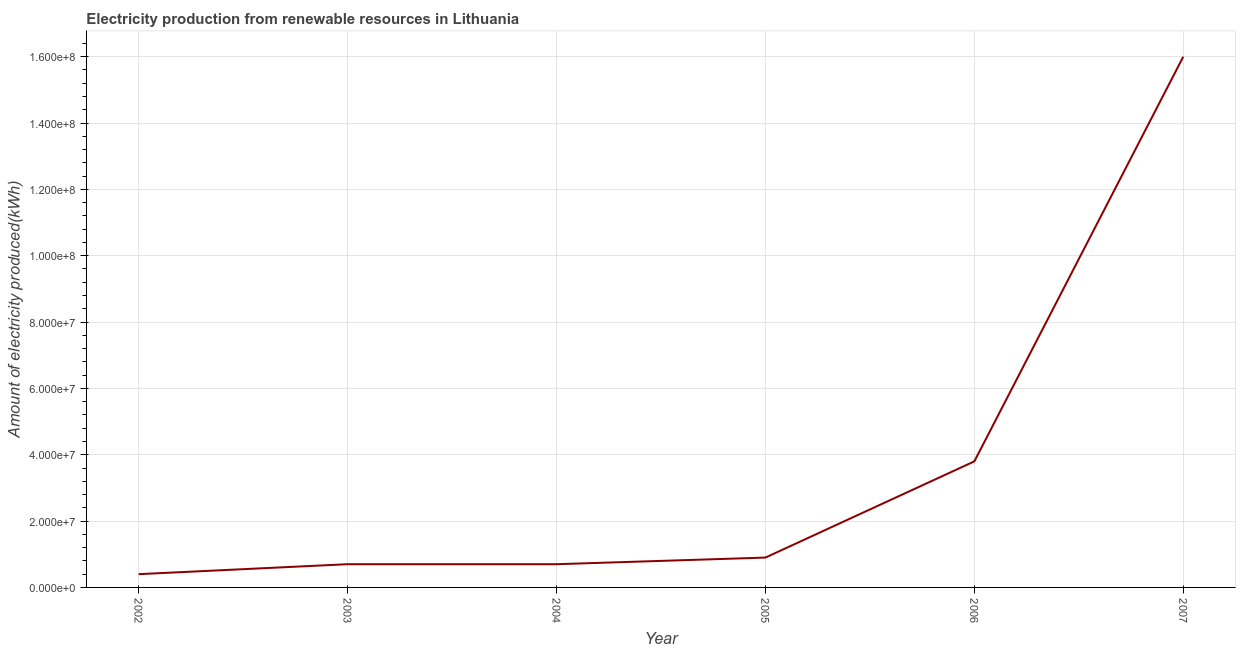What is the amount of electricity produced in 2007?
Your answer should be compact. 1.60e+08. Across all years, what is the maximum amount of electricity produced?
Your answer should be compact. 1.60e+08. Across all years, what is the minimum amount of electricity produced?
Offer a terse response. 4.00e+06. In which year was the amount of electricity produced maximum?
Keep it short and to the point. 2007. In which year was the amount of electricity produced minimum?
Ensure brevity in your answer.  2002. What is the sum of the amount of electricity produced?
Make the answer very short. 2.25e+08. What is the difference between the amount of electricity produced in 2006 and 2007?
Your answer should be compact. -1.22e+08. What is the average amount of electricity produced per year?
Provide a succinct answer. 3.75e+07. In how many years, is the amount of electricity produced greater than 160000000 kWh?
Provide a succinct answer. 0. Do a majority of the years between 2005 and 2007 (inclusive) have amount of electricity produced greater than 76000000 kWh?
Give a very brief answer. No. What is the ratio of the amount of electricity produced in 2005 to that in 2006?
Provide a short and direct response. 0.24. What is the difference between the highest and the second highest amount of electricity produced?
Offer a very short reply. 1.22e+08. Is the sum of the amount of electricity produced in 2004 and 2005 greater than the maximum amount of electricity produced across all years?
Keep it short and to the point. No. What is the difference between the highest and the lowest amount of electricity produced?
Give a very brief answer. 1.56e+08. Does the amount of electricity produced monotonically increase over the years?
Ensure brevity in your answer.  No. How many years are there in the graph?
Provide a short and direct response. 6. What is the difference between two consecutive major ticks on the Y-axis?
Provide a short and direct response. 2.00e+07. What is the title of the graph?
Give a very brief answer. Electricity production from renewable resources in Lithuania. What is the label or title of the X-axis?
Provide a succinct answer. Year. What is the label or title of the Y-axis?
Give a very brief answer. Amount of electricity produced(kWh). What is the Amount of electricity produced(kWh) of 2003?
Give a very brief answer. 7.00e+06. What is the Amount of electricity produced(kWh) in 2004?
Provide a succinct answer. 7.00e+06. What is the Amount of electricity produced(kWh) of 2005?
Ensure brevity in your answer.  9.00e+06. What is the Amount of electricity produced(kWh) in 2006?
Provide a short and direct response. 3.80e+07. What is the Amount of electricity produced(kWh) of 2007?
Ensure brevity in your answer.  1.60e+08. What is the difference between the Amount of electricity produced(kWh) in 2002 and 2003?
Keep it short and to the point. -3.00e+06. What is the difference between the Amount of electricity produced(kWh) in 2002 and 2005?
Your answer should be very brief. -5.00e+06. What is the difference between the Amount of electricity produced(kWh) in 2002 and 2006?
Provide a short and direct response. -3.40e+07. What is the difference between the Amount of electricity produced(kWh) in 2002 and 2007?
Offer a very short reply. -1.56e+08. What is the difference between the Amount of electricity produced(kWh) in 2003 and 2004?
Provide a short and direct response. 0. What is the difference between the Amount of electricity produced(kWh) in 2003 and 2005?
Make the answer very short. -2.00e+06. What is the difference between the Amount of electricity produced(kWh) in 2003 and 2006?
Give a very brief answer. -3.10e+07. What is the difference between the Amount of electricity produced(kWh) in 2003 and 2007?
Your answer should be very brief. -1.53e+08. What is the difference between the Amount of electricity produced(kWh) in 2004 and 2005?
Provide a short and direct response. -2.00e+06. What is the difference between the Amount of electricity produced(kWh) in 2004 and 2006?
Keep it short and to the point. -3.10e+07. What is the difference between the Amount of electricity produced(kWh) in 2004 and 2007?
Offer a very short reply. -1.53e+08. What is the difference between the Amount of electricity produced(kWh) in 2005 and 2006?
Your answer should be compact. -2.90e+07. What is the difference between the Amount of electricity produced(kWh) in 2005 and 2007?
Your answer should be compact. -1.51e+08. What is the difference between the Amount of electricity produced(kWh) in 2006 and 2007?
Make the answer very short. -1.22e+08. What is the ratio of the Amount of electricity produced(kWh) in 2002 to that in 2003?
Your response must be concise. 0.57. What is the ratio of the Amount of electricity produced(kWh) in 2002 to that in 2004?
Your response must be concise. 0.57. What is the ratio of the Amount of electricity produced(kWh) in 2002 to that in 2005?
Provide a succinct answer. 0.44. What is the ratio of the Amount of electricity produced(kWh) in 2002 to that in 2006?
Provide a succinct answer. 0.1. What is the ratio of the Amount of electricity produced(kWh) in 2002 to that in 2007?
Keep it short and to the point. 0.03. What is the ratio of the Amount of electricity produced(kWh) in 2003 to that in 2004?
Your answer should be very brief. 1. What is the ratio of the Amount of electricity produced(kWh) in 2003 to that in 2005?
Provide a succinct answer. 0.78. What is the ratio of the Amount of electricity produced(kWh) in 2003 to that in 2006?
Offer a very short reply. 0.18. What is the ratio of the Amount of electricity produced(kWh) in 2003 to that in 2007?
Provide a succinct answer. 0.04. What is the ratio of the Amount of electricity produced(kWh) in 2004 to that in 2005?
Give a very brief answer. 0.78. What is the ratio of the Amount of electricity produced(kWh) in 2004 to that in 2006?
Offer a terse response. 0.18. What is the ratio of the Amount of electricity produced(kWh) in 2004 to that in 2007?
Make the answer very short. 0.04. What is the ratio of the Amount of electricity produced(kWh) in 2005 to that in 2006?
Give a very brief answer. 0.24. What is the ratio of the Amount of electricity produced(kWh) in 2005 to that in 2007?
Make the answer very short. 0.06. What is the ratio of the Amount of electricity produced(kWh) in 2006 to that in 2007?
Keep it short and to the point. 0.24. 